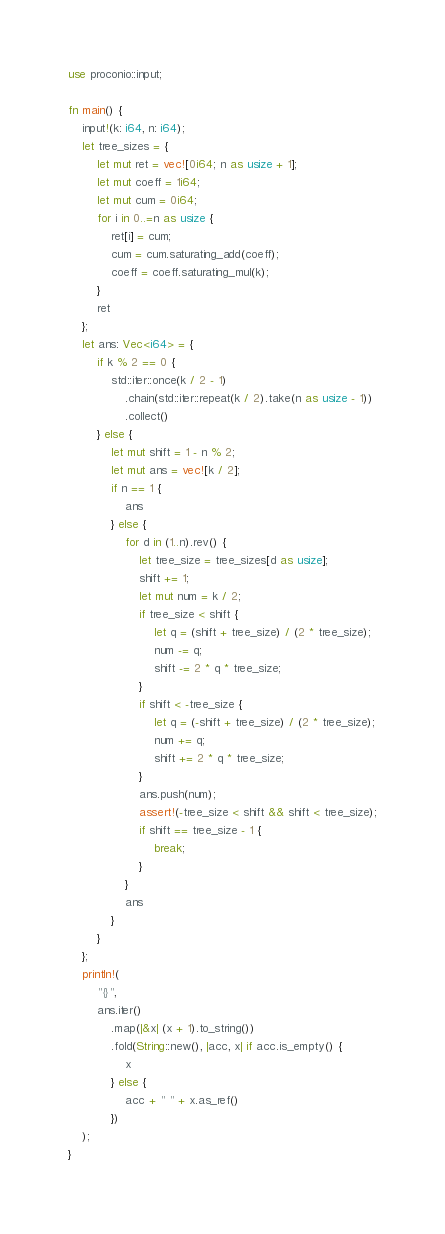Convert code to text. <code><loc_0><loc_0><loc_500><loc_500><_Rust_>use proconio::input;

fn main() {
    input!(k: i64, n: i64);
    let tree_sizes = {
        let mut ret = vec![0i64; n as usize + 1];
        let mut coeff = 1i64;
        let mut cum = 0i64;
        for i in 0..=n as usize {
            ret[i] = cum;
            cum = cum.saturating_add(coeff);
            coeff = coeff.saturating_mul(k);
        }
        ret
    };
    let ans: Vec<i64> = {
        if k % 2 == 0 {
            std::iter::once(k / 2 - 1)
                .chain(std::iter::repeat(k / 2).take(n as usize - 1))
                .collect()
        } else {
            let mut shift = 1 - n % 2;
            let mut ans = vec![k / 2];
            if n == 1 {
                ans
            } else {
                for d in (1..n).rev() {
                    let tree_size = tree_sizes[d as usize];
                    shift += 1;
                    let mut num = k / 2;
                    if tree_size < shift {
                        let q = (shift + tree_size) / (2 * tree_size);
                        num -= q;
                        shift -= 2 * q * tree_size;
                    }
                    if shift < -tree_size {
                        let q = (-shift + tree_size) / (2 * tree_size);
                        num += q;
                        shift += 2 * q * tree_size;
                    }
                    ans.push(num);
                    assert!(-tree_size < shift && shift < tree_size);
                    if shift == tree_size - 1 {
                        break;
                    }
                }
                ans
            }
        }
    };
    println!(
        "{}",
        ans.iter()
            .map(|&x| (x + 1).to_string())
            .fold(String::new(), |acc, x| if acc.is_empty() {
                x
            } else {
                acc + " " + x.as_ref()
            })
    );
}
</code> 